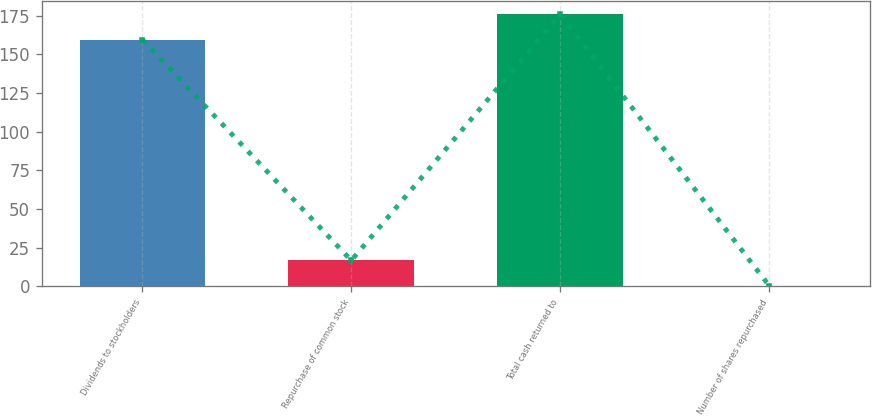Convert chart to OTSL. <chart><loc_0><loc_0><loc_500><loc_500><bar_chart><fcel>Dividends to stockholders<fcel>Repurchase of common stock<fcel>Total cash returned to<fcel>Number of shares repurchased<nl><fcel>159.5<fcel>16.63<fcel>175.83<fcel>0.3<nl></chart> 